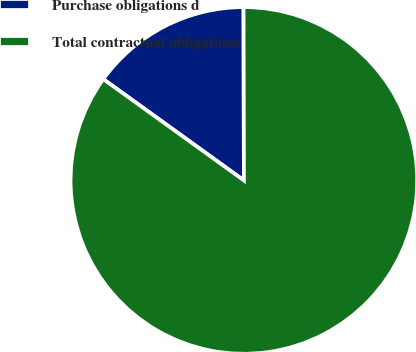Convert chart to OTSL. <chart><loc_0><loc_0><loc_500><loc_500><pie_chart><fcel>Purchase obligations d<fcel>Total contractual obligations<nl><fcel>15.03%<fcel>84.97%<nl></chart> 